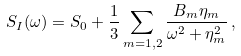<formula> <loc_0><loc_0><loc_500><loc_500>S _ { I } ( \omega ) = S _ { 0 } + \frac { 1 } { 3 } \sum _ { m = 1 , 2 } \frac { B _ { m } \eta _ { m } } { \omega ^ { 2 } + \eta _ { m } ^ { 2 } } \, ,</formula> 